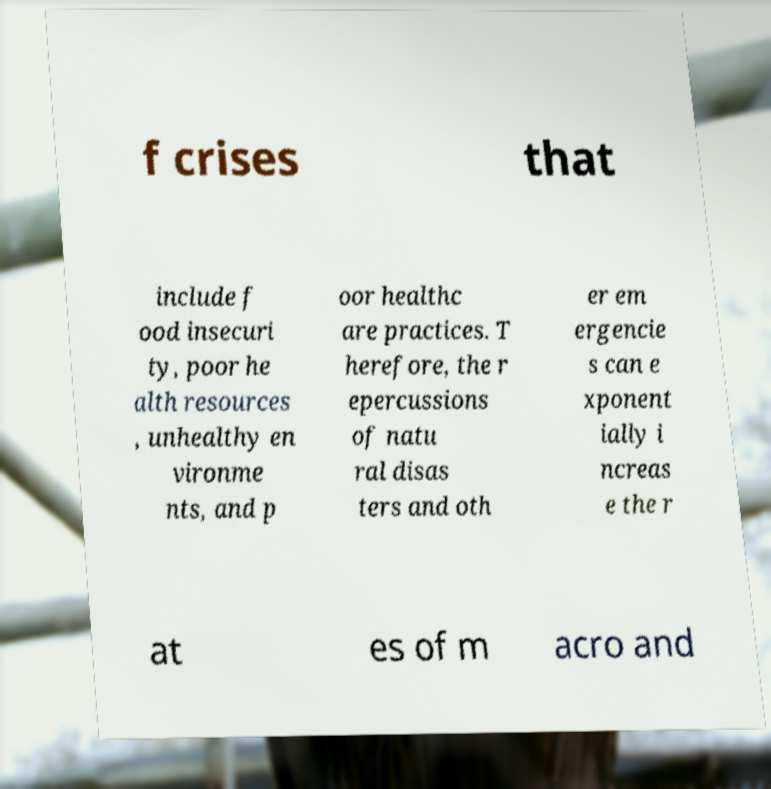There's text embedded in this image that I need extracted. Can you transcribe it verbatim? f crises that include f ood insecuri ty, poor he alth resources , unhealthy en vironme nts, and p oor healthc are practices. T herefore, the r epercussions of natu ral disas ters and oth er em ergencie s can e xponent ially i ncreas e the r at es of m acro and 